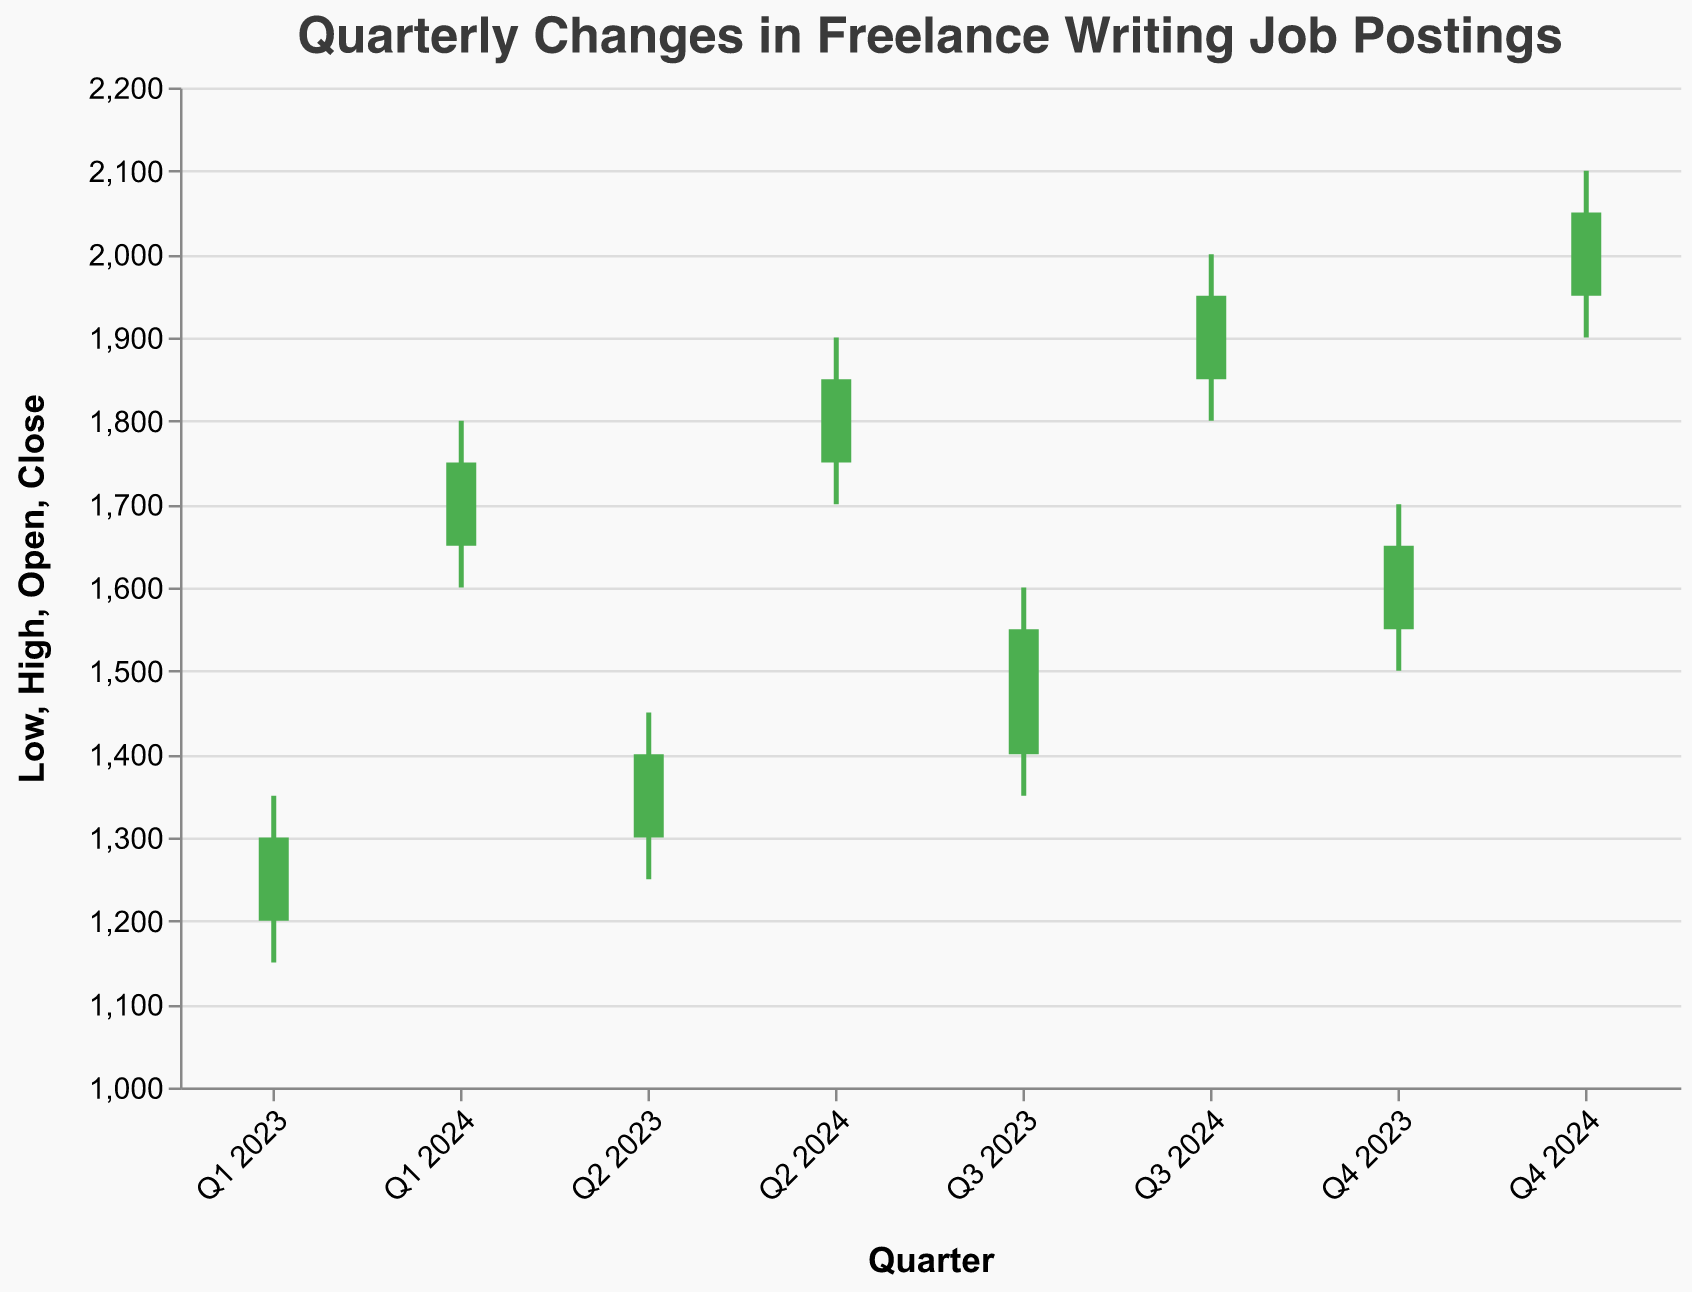What is the title of the figure? The title of the figure is located at the top and it states the main subject or data represented in the chart.
Answer: Quarterly Changes in Freelance Writing Job Postings How many quarters of data are presented in the figure? Count the total unique quarter labels along the x-axis in the chart.
Answer: 8 What is the highest 'High' value recorded in the figure? Look at the 'High' values for each quarter and identify the maximum one. For Q4 2024, the high value is 2100.
Answer: 2100 During which quarter did the 'Close' value first reach 1750? Trace each quarter's 'Close' value in the figure until you find the first occurrence of 1750. For Q1 2024, the close value is 1750.
Answer: Q1 2024 Which quarter had the smallest range between 'High' and 'Low' values? Calculate the range (High - Low) for each quarter and find the smallest range. For Q2 2023, the range is 1450 - 1250 = 200.
Answer: Q2 2023 How much did the 'Close' value increase from Q1 2023 to Q4 2024? Calculate the difference between the 'Close' values of Q1 2023 and Q4 2024. (2050 - 1300).
Answer: 750 Which quarter experienced the highest increase in 'Open' value compared to the previous quarter? Calculate the difference in 'Open' values between each consecutive quarter and identify the largest increase. From Q4 2023 to Q1 2024, the increase is 1650 - 1550 = 100.
Answer: Q1 2024 Did the 'Close' value ever decrease over any quarter? Compare the 'Close' values of consecutive quarters to see if there was any decrease. Every quarter shows an increase in 'Close' values.
Answer: No What is the average 'Close' value for all the quarters presented? Sum all the 'Close' values and divide by the total number of quarters. (1300+1400+1550+1650+1750+1850+1950+2050) / 8.
Answer: 1681.25 